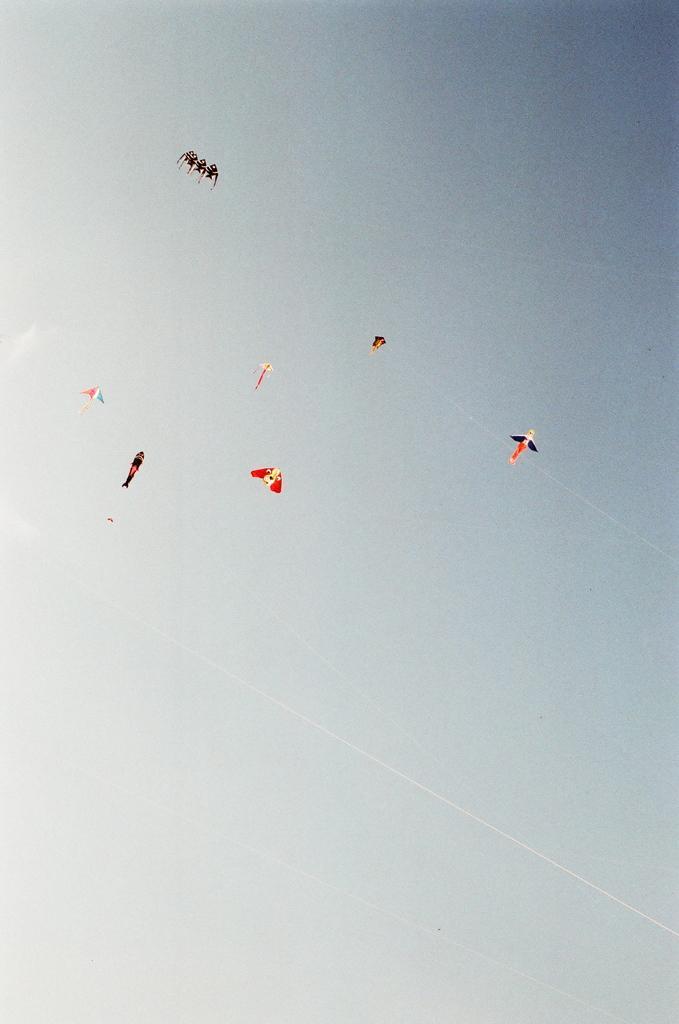In one or two sentences, can you explain what this image depicts? In the image we can see kites are flying in the sky. 